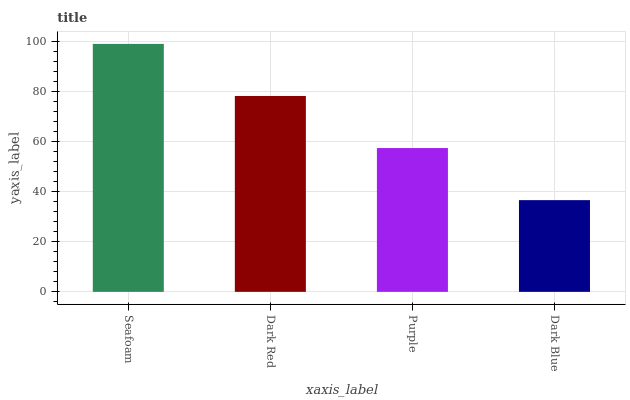Is Dark Blue the minimum?
Answer yes or no. Yes. Is Seafoam the maximum?
Answer yes or no. Yes. Is Dark Red the minimum?
Answer yes or no. No. Is Dark Red the maximum?
Answer yes or no. No. Is Seafoam greater than Dark Red?
Answer yes or no. Yes. Is Dark Red less than Seafoam?
Answer yes or no. Yes. Is Dark Red greater than Seafoam?
Answer yes or no. No. Is Seafoam less than Dark Red?
Answer yes or no. No. Is Dark Red the high median?
Answer yes or no. Yes. Is Purple the low median?
Answer yes or no. Yes. Is Dark Blue the high median?
Answer yes or no. No. Is Dark Red the low median?
Answer yes or no. No. 